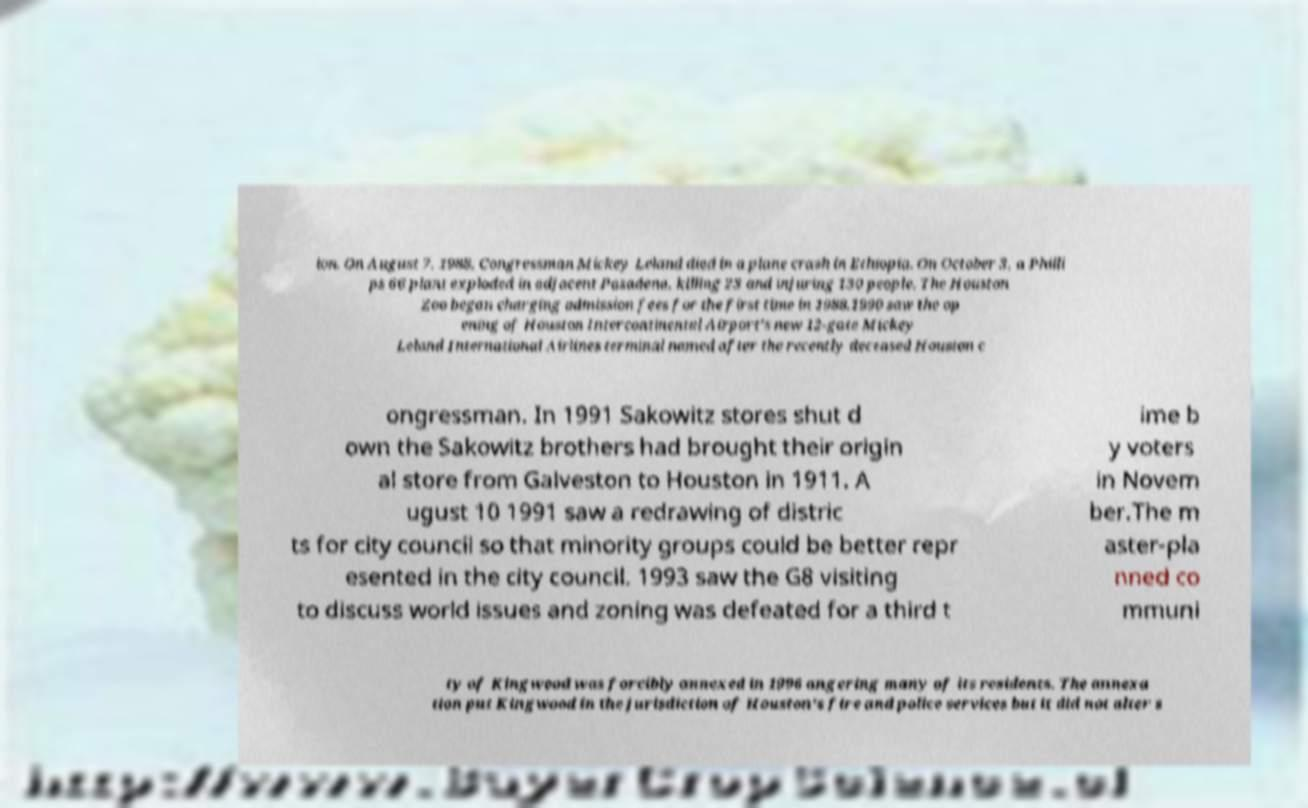Could you extract and type out the text from this image? ion. On August 7, 1988, Congressman Mickey Leland died in a plane crash in Ethiopia. On October 3, a Philli ps 66 plant exploded in adjacent Pasadena, killing 23 and injuring 130 people. The Houston Zoo began charging admission fees for the first time in 1988.1990 saw the op ening of Houston Intercontinental Airport's new 12-gate Mickey Leland International Airlines terminal named after the recently deceased Houston c ongressman. In 1991 Sakowitz stores shut d own the Sakowitz brothers had brought their origin al store from Galveston to Houston in 1911. A ugust 10 1991 saw a redrawing of distric ts for city council so that minority groups could be better repr esented in the city council. 1993 saw the G8 visiting to discuss world issues and zoning was defeated for a third t ime b y voters in Novem ber.The m aster-pla nned co mmuni ty of Kingwood was forcibly annexed in 1996 angering many of its residents. The annexa tion put Kingwood in the jurisdiction of Houston's fire and police services but it did not alter s 